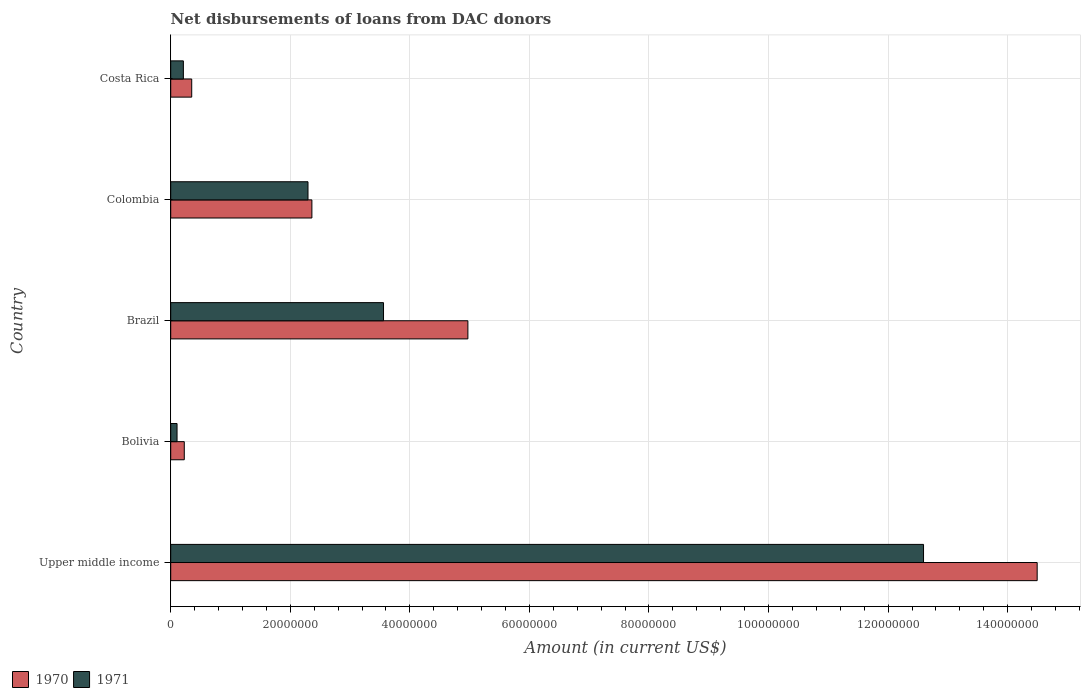Are the number of bars on each tick of the Y-axis equal?
Provide a short and direct response. Yes. How many bars are there on the 4th tick from the bottom?
Offer a very short reply. 2. What is the label of the 5th group of bars from the top?
Give a very brief answer. Upper middle income. In how many cases, is the number of bars for a given country not equal to the number of legend labels?
Provide a succinct answer. 0. What is the amount of loans disbursed in 1970 in Colombia?
Offer a terse response. 2.36e+07. Across all countries, what is the maximum amount of loans disbursed in 1970?
Give a very brief answer. 1.45e+08. Across all countries, what is the minimum amount of loans disbursed in 1970?
Offer a very short reply. 2.27e+06. In which country was the amount of loans disbursed in 1970 maximum?
Provide a succinct answer. Upper middle income. What is the total amount of loans disbursed in 1970 in the graph?
Give a very brief answer. 2.24e+08. What is the difference between the amount of loans disbursed in 1971 in Brazil and that in Upper middle income?
Make the answer very short. -9.03e+07. What is the difference between the amount of loans disbursed in 1971 in Brazil and the amount of loans disbursed in 1970 in Upper middle income?
Provide a short and direct response. -1.09e+08. What is the average amount of loans disbursed in 1971 per country?
Make the answer very short. 3.75e+07. What is the difference between the amount of loans disbursed in 1970 and amount of loans disbursed in 1971 in Costa Rica?
Ensure brevity in your answer.  1.40e+06. In how many countries, is the amount of loans disbursed in 1971 greater than 68000000 US$?
Give a very brief answer. 1. What is the ratio of the amount of loans disbursed in 1971 in Brazil to that in Upper middle income?
Your answer should be very brief. 0.28. Is the amount of loans disbursed in 1971 in Bolivia less than that in Upper middle income?
Provide a succinct answer. Yes. What is the difference between the highest and the second highest amount of loans disbursed in 1971?
Ensure brevity in your answer.  9.03e+07. What is the difference between the highest and the lowest amount of loans disbursed in 1970?
Offer a terse response. 1.43e+08. What does the 2nd bar from the top in Upper middle income represents?
Give a very brief answer. 1970. What does the 2nd bar from the bottom in Costa Rica represents?
Offer a terse response. 1971. How many bars are there?
Provide a short and direct response. 10. How many countries are there in the graph?
Ensure brevity in your answer.  5. Does the graph contain any zero values?
Offer a very short reply. No. Does the graph contain grids?
Provide a succinct answer. Yes. Where does the legend appear in the graph?
Provide a short and direct response. Bottom left. How many legend labels are there?
Offer a terse response. 2. How are the legend labels stacked?
Offer a very short reply. Horizontal. What is the title of the graph?
Offer a terse response. Net disbursements of loans from DAC donors. What is the label or title of the Y-axis?
Offer a terse response. Country. What is the Amount (in current US$) in 1970 in Upper middle income?
Your response must be concise. 1.45e+08. What is the Amount (in current US$) of 1971 in Upper middle income?
Your response must be concise. 1.26e+08. What is the Amount (in current US$) of 1970 in Bolivia?
Offer a very short reply. 2.27e+06. What is the Amount (in current US$) of 1971 in Bolivia?
Ensure brevity in your answer.  1.06e+06. What is the Amount (in current US$) in 1970 in Brazil?
Your answer should be compact. 4.97e+07. What is the Amount (in current US$) in 1971 in Brazil?
Give a very brief answer. 3.56e+07. What is the Amount (in current US$) in 1970 in Colombia?
Offer a terse response. 2.36e+07. What is the Amount (in current US$) of 1971 in Colombia?
Your answer should be very brief. 2.30e+07. What is the Amount (in current US$) of 1970 in Costa Rica?
Make the answer very short. 3.51e+06. What is the Amount (in current US$) in 1971 in Costa Rica?
Your response must be concise. 2.12e+06. Across all countries, what is the maximum Amount (in current US$) in 1970?
Provide a short and direct response. 1.45e+08. Across all countries, what is the maximum Amount (in current US$) of 1971?
Your answer should be very brief. 1.26e+08. Across all countries, what is the minimum Amount (in current US$) in 1970?
Provide a succinct answer. 2.27e+06. Across all countries, what is the minimum Amount (in current US$) of 1971?
Your answer should be compact. 1.06e+06. What is the total Amount (in current US$) of 1970 in the graph?
Provide a succinct answer. 2.24e+08. What is the total Amount (in current US$) of 1971 in the graph?
Your answer should be very brief. 1.88e+08. What is the difference between the Amount (in current US$) in 1970 in Upper middle income and that in Bolivia?
Provide a succinct answer. 1.43e+08. What is the difference between the Amount (in current US$) in 1971 in Upper middle income and that in Bolivia?
Provide a short and direct response. 1.25e+08. What is the difference between the Amount (in current US$) in 1970 in Upper middle income and that in Brazil?
Provide a short and direct response. 9.52e+07. What is the difference between the Amount (in current US$) of 1971 in Upper middle income and that in Brazil?
Your response must be concise. 9.03e+07. What is the difference between the Amount (in current US$) of 1970 in Upper middle income and that in Colombia?
Offer a terse response. 1.21e+08. What is the difference between the Amount (in current US$) of 1971 in Upper middle income and that in Colombia?
Your response must be concise. 1.03e+08. What is the difference between the Amount (in current US$) of 1970 in Upper middle income and that in Costa Rica?
Ensure brevity in your answer.  1.41e+08. What is the difference between the Amount (in current US$) in 1971 in Upper middle income and that in Costa Rica?
Give a very brief answer. 1.24e+08. What is the difference between the Amount (in current US$) in 1970 in Bolivia and that in Brazil?
Your answer should be very brief. -4.74e+07. What is the difference between the Amount (in current US$) in 1971 in Bolivia and that in Brazil?
Ensure brevity in your answer.  -3.45e+07. What is the difference between the Amount (in current US$) in 1970 in Bolivia and that in Colombia?
Offer a very short reply. -2.13e+07. What is the difference between the Amount (in current US$) in 1971 in Bolivia and that in Colombia?
Your response must be concise. -2.19e+07. What is the difference between the Amount (in current US$) in 1970 in Bolivia and that in Costa Rica?
Make the answer very short. -1.24e+06. What is the difference between the Amount (in current US$) in 1971 in Bolivia and that in Costa Rica?
Your response must be concise. -1.06e+06. What is the difference between the Amount (in current US$) in 1970 in Brazil and that in Colombia?
Keep it short and to the point. 2.61e+07. What is the difference between the Amount (in current US$) of 1971 in Brazil and that in Colombia?
Ensure brevity in your answer.  1.26e+07. What is the difference between the Amount (in current US$) in 1970 in Brazil and that in Costa Rica?
Ensure brevity in your answer.  4.62e+07. What is the difference between the Amount (in current US$) of 1971 in Brazil and that in Costa Rica?
Your answer should be compact. 3.35e+07. What is the difference between the Amount (in current US$) in 1970 in Colombia and that in Costa Rica?
Your answer should be compact. 2.01e+07. What is the difference between the Amount (in current US$) in 1971 in Colombia and that in Costa Rica?
Your answer should be compact. 2.08e+07. What is the difference between the Amount (in current US$) in 1970 in Upper middle income and the Amount (in current US$) in 1971 in Bolivia?
Your answer should be compact. 1.44e+08. What is the difference between the Amount (in current US$) in 1970 in Upper middle income and the Amount (in current US$) in 1971 in Brazil?
Provide a succinct answer. 1.09e+08. What is the difference between the Amount (in current US$) in 1970 in Upper middle income and the Amount (in current US$) in 1971 in Colombia?
Offer a terse response. 1.22e+08. What is the difference between the Amount (in current US$) in 1970 in Upper middle income and the Amount (in current US$) in 1971 in Costa Rica?
Keep it short and to the point. 1.43e+08. What is the difference between the Amount (in current US$) of 1970 in Bolivia and the Amount (in current US$) of 1971 in Brazil?
Provide a succinct answer. -3.33e+07. What is the difference between the Amount (in current US$) of 1970 in Bolivia and the Amount (in current US$) of 1971 in Colombia?
Provide a short and direct response. -2.07e+07. What is the difference between the Amount (in current US$) in 1970 in Bolivia and the Amount (in current US$) in 1971 in Costa Rica?
Your answer should be very brief. 1.54e+05. What is the difference between the Amount (in current US$) of 1970 in Brazil and the Amount (in current US$) of 1971 in Colombia?
Ensure brevity in your answer.  2.67e+07. What is the difference between the Amount (in current US$) of 1970 in Brazil and the Amount (in current US$) of 1971 in Costa Rica?
Make the answer very short. 4.76e+07. What is the difference between the Amount (in current US$) of 1970 in Colombia and the Amount (in current US$) of 1971 in Costa Rica?
Your answer should be compact. 2.15e+07. What is the average Amount (in current US$) in 1970 per country?
Your answer should be very brief. 4.48e+07. What is the average Amount (in current US$) in 1971 per country?
Make the answer very short. 3.75e+07. What is the difference between the Amount (in current US$) in 1970 and Amount (in current US$) in 1971 in Upper middle income?
Offer a terse response. 1.90e+07. What is the difference between the Amount (in current US$) of 1970 and Amount (in current US$) of 1971 in Bolivia?
Your response must be concise. 1.21e+06. What is the difference between the Amount (in current US$) in 1970 and Amount (in current US$) in 1971 in Brazil?
Give a very brief answer. 1.41e+07. What is the difference between the Amount (in current US$) of 1970 and Amount (in current US$) of 1971 in Colombia?
Keep it short and to the point. 6.52e+05. What is the difference between the Amount (in current US$) of 1970 and Amount (in current US$) of 1971 in Costa Rica?
Offer a very short reply. 1.40e+06. What is the ratio of the Amount (in current US$) of 1970 in Upper middle income to that in Bolivia?
Offer a terse response. 63.85. What is the ratio of the Amount (in current US$) of 1971 in Upper middle income to that in Bolivia?
Ensure brevity in your answer.  119.02. What is the ratio of the Amount (in current US$) of 1970 in Upper middle income to that in Brazil?
Give a very brief answer. 2.92. What is the ratio of the Amount (in current US$) of 1971 in Upper middle income to that in Brazil?
Make the answer very short. 3.54. What is the ratio of the Amount (in current US$) of 1970 in Upper middle income to that in Colombia?
Your answer should be compact. 6.14. What is the ratio of the Amount (in current US$) of 1971 in Upper middle income to that in Colombia?
Offer a terse response. 5.48. What is the ratio of the Amount (in current US$) of 1970 in Upper middle income to that in Costa Rica?
Offer a terse response. 41.26. What is the ratio of the Amount (in current US$) in 1971 in Upper middle income to that in Costa Rica?
Give a very brief answer. 59.51. What is the ratio of the Amount (in current US$) in 1970 in Bolivia to that in Brazil?
Offer a very short reply. 0.05. What is the ratio of the Amount (in current US$) in 1971 in Bolivia to that in Brazil?
Your answer should be compact. 0.03. What is the ratio of the Amount (in current US$) in 1970 in Bolivia to that in Colombia?
Keep it short and to the point. 0.1. What is the ratio of the Amount (in current US$) in 1971 in Bolivia to that in Colombia?
Make the answer very short. 0.05. What is the ratio of the Amount (in current US$) in 1970 in Bolivia to that in Costa Rica?
Ensure brevity in your answer.  0.65. What is the ratio of the Amount (in current US$) of 1970 in Brazil to that in Colombia?
Your response must be concise. 2.1. What is the ratio of the Amount (in current US$) in 1971 in Brazil to that in Colombia?
Keep it short and to the point. 1.55. What is the ratio of the Amount (in current US$) in 1970 in Brazil to that in Costa Rica?
Offer a very short reply. 14.15. What is the ratio of the Amount (in current US$) in 1971 in Brazil to that in Costa Rica?
Give a very brief answer. 16.82. What is the ratio of the Amount (in current US$) of 1970 in Colombia to that in Costa Rica?
Provide a succinct answer. 6.72. What is the ratio of the Amount (in current US$) in 1971 in Colombia to that in Costa Rica?
Provide a short and direct response. 10.85. What is the difference between the highest and the second highest Amount (in current US$) of 1970?
Provide a succinct answer. 9.52e+07. What is the difference between the highest and the second highest Amount (in current US$) of 1971?
Make the answer very short. 9.03e+07. What is the difference between the highest and the lowest Amount (in current US$) of 1970?
Ensure brevity in your answer.  1.43e+08. What is the difference between the highest and the lowest Amount (in current US$) of 1971?
Your answer should be very brief. 1.25e+08. 